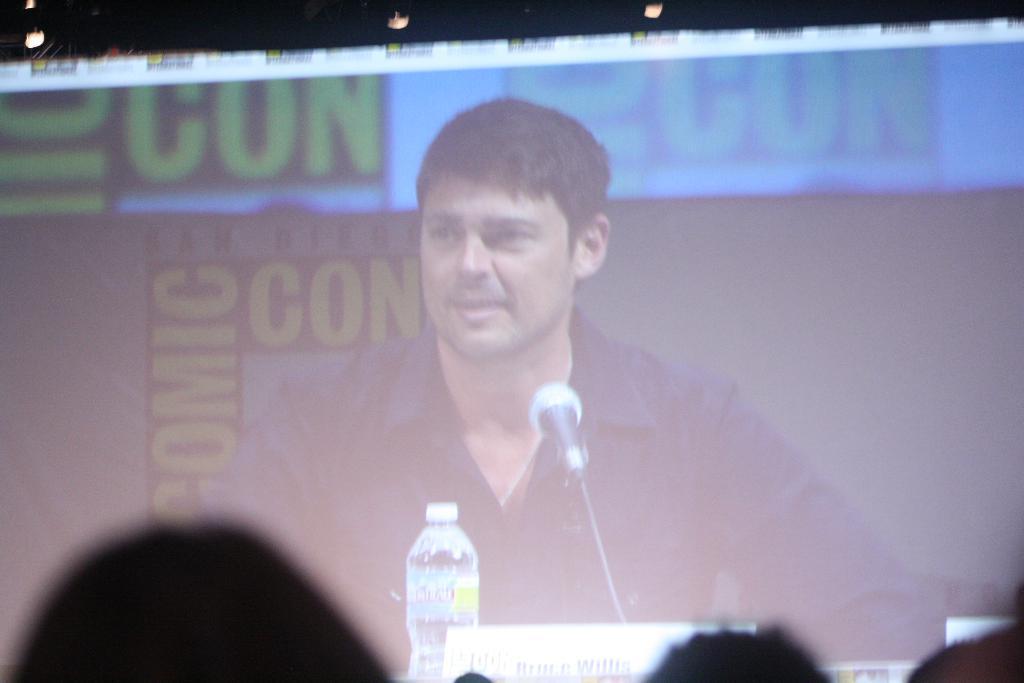In one or two sentences, can you explain what this image depicts? In this image we can see a display screen. In that we can see a person sitting. We can also see a bottle, mic with a stand and a name board in front of him. On the bottom of the image we can see some people. 